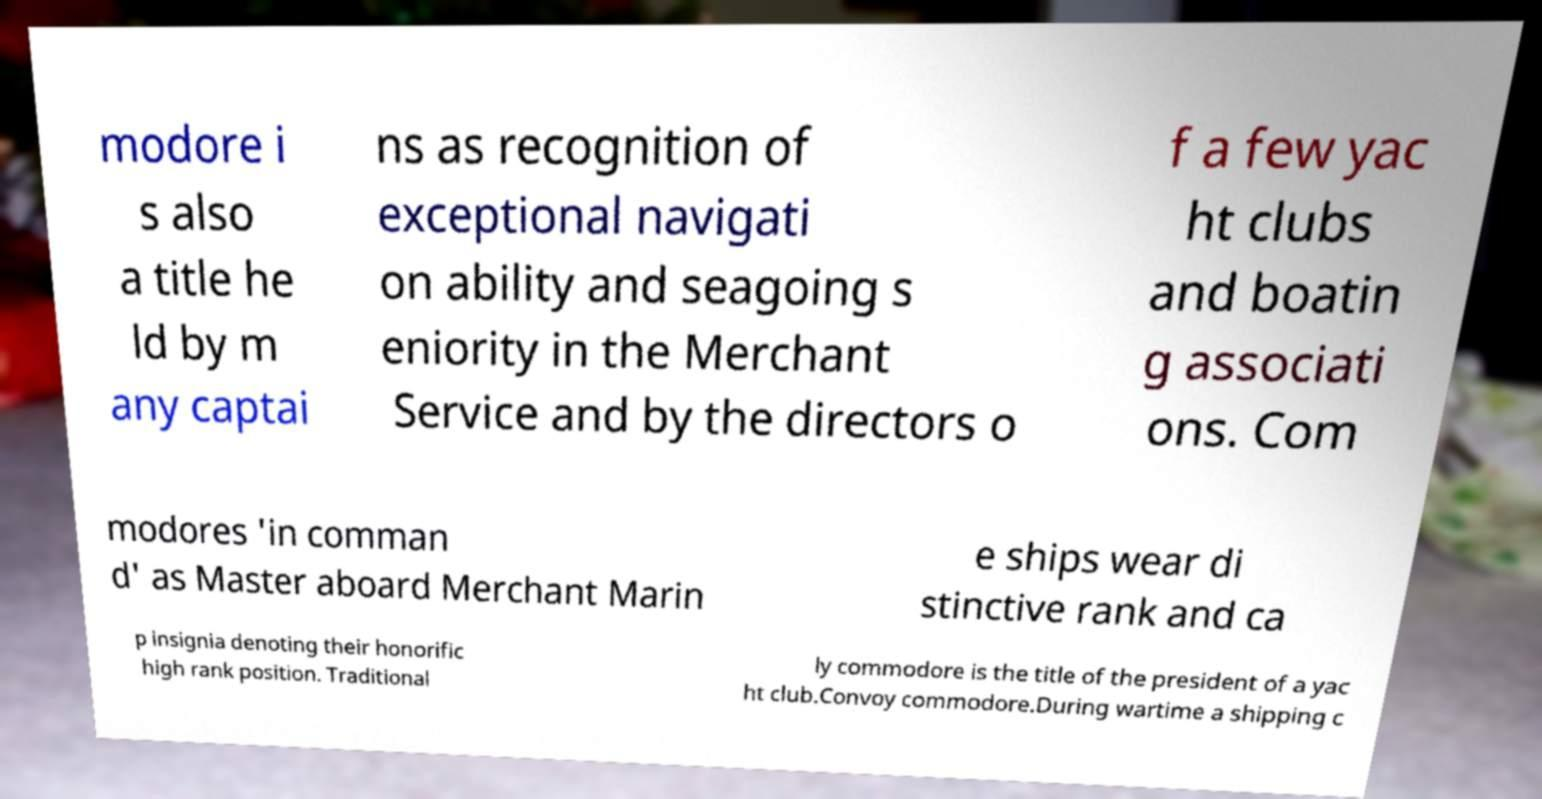Please identify and transcribe the text found in this image. modore i s also a title he ld by m any captai ns as recognition of exceptional navigati on ability and seagoing s eniority in the Merchant Service and by the directors o f a few yac ht clubs and boatin g associati ons. Com modores 'in comman d' as Master aboard Merchant Marin e ships wear di stinctive rank and ca p insignia denoting their honorific high rank position. Traditional ly commodore is the title of the president of a yac ht club.Convoy commodore.During wartime a shipping c 